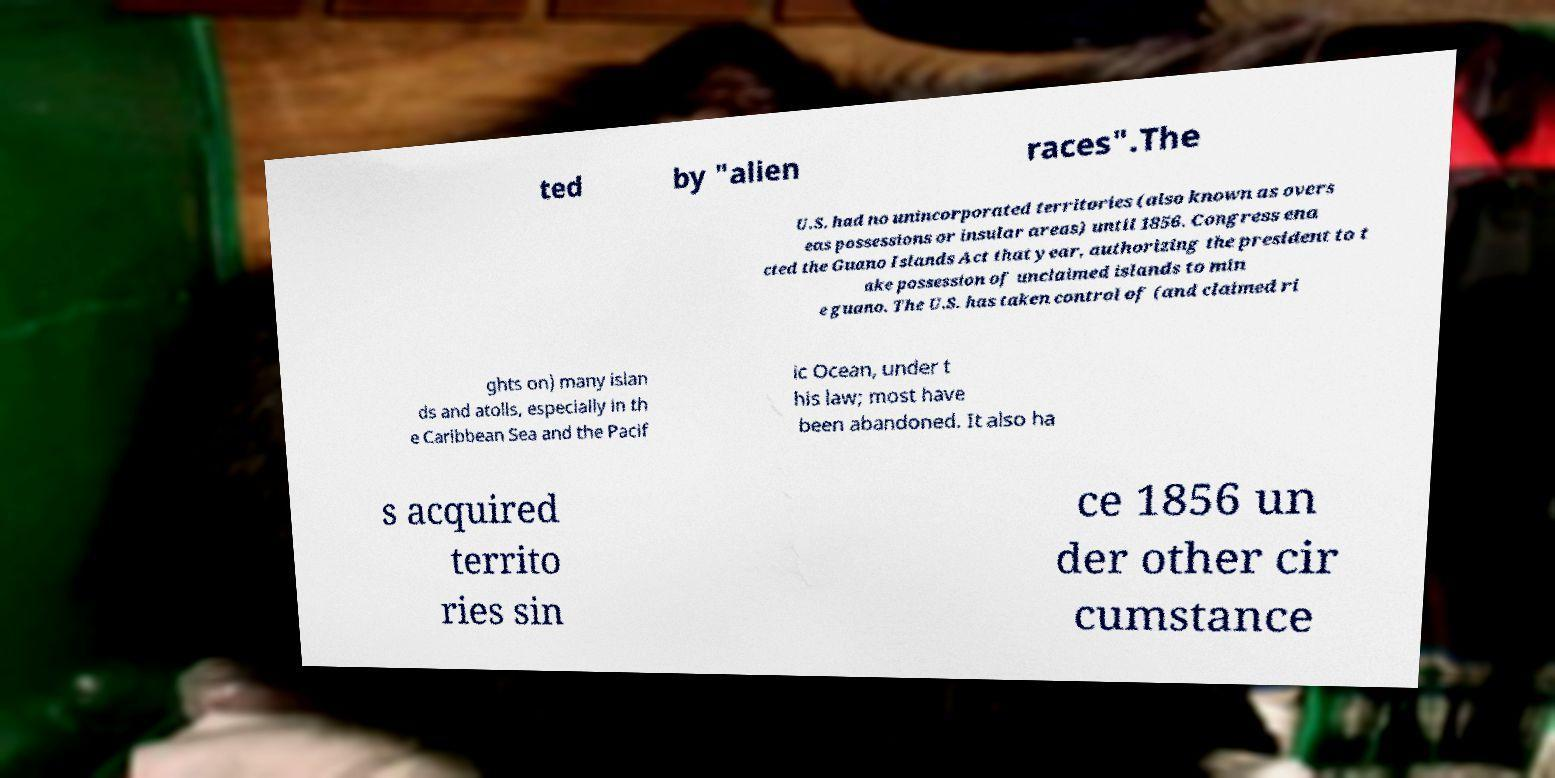Can you accurately transcribe the text from the provided image for me? ted by "alien races".The U.S. had no unincorporated territories (also known as overs eas possessions or insular areas) until 1856. Congress ena cted the Guano Islands Act that year, authorizing the president to t ake possession of unclaimed islands to min e guano. The U.S. has taken control of (and claimed ri ghts on) many islan ds and atolls, especially in th e Caribbean Sea and the Pacif ic Ocean, under t his law; most have been abandoned. It also ha s acquired territo ries sin ce 1856 un der other cir cumstance 